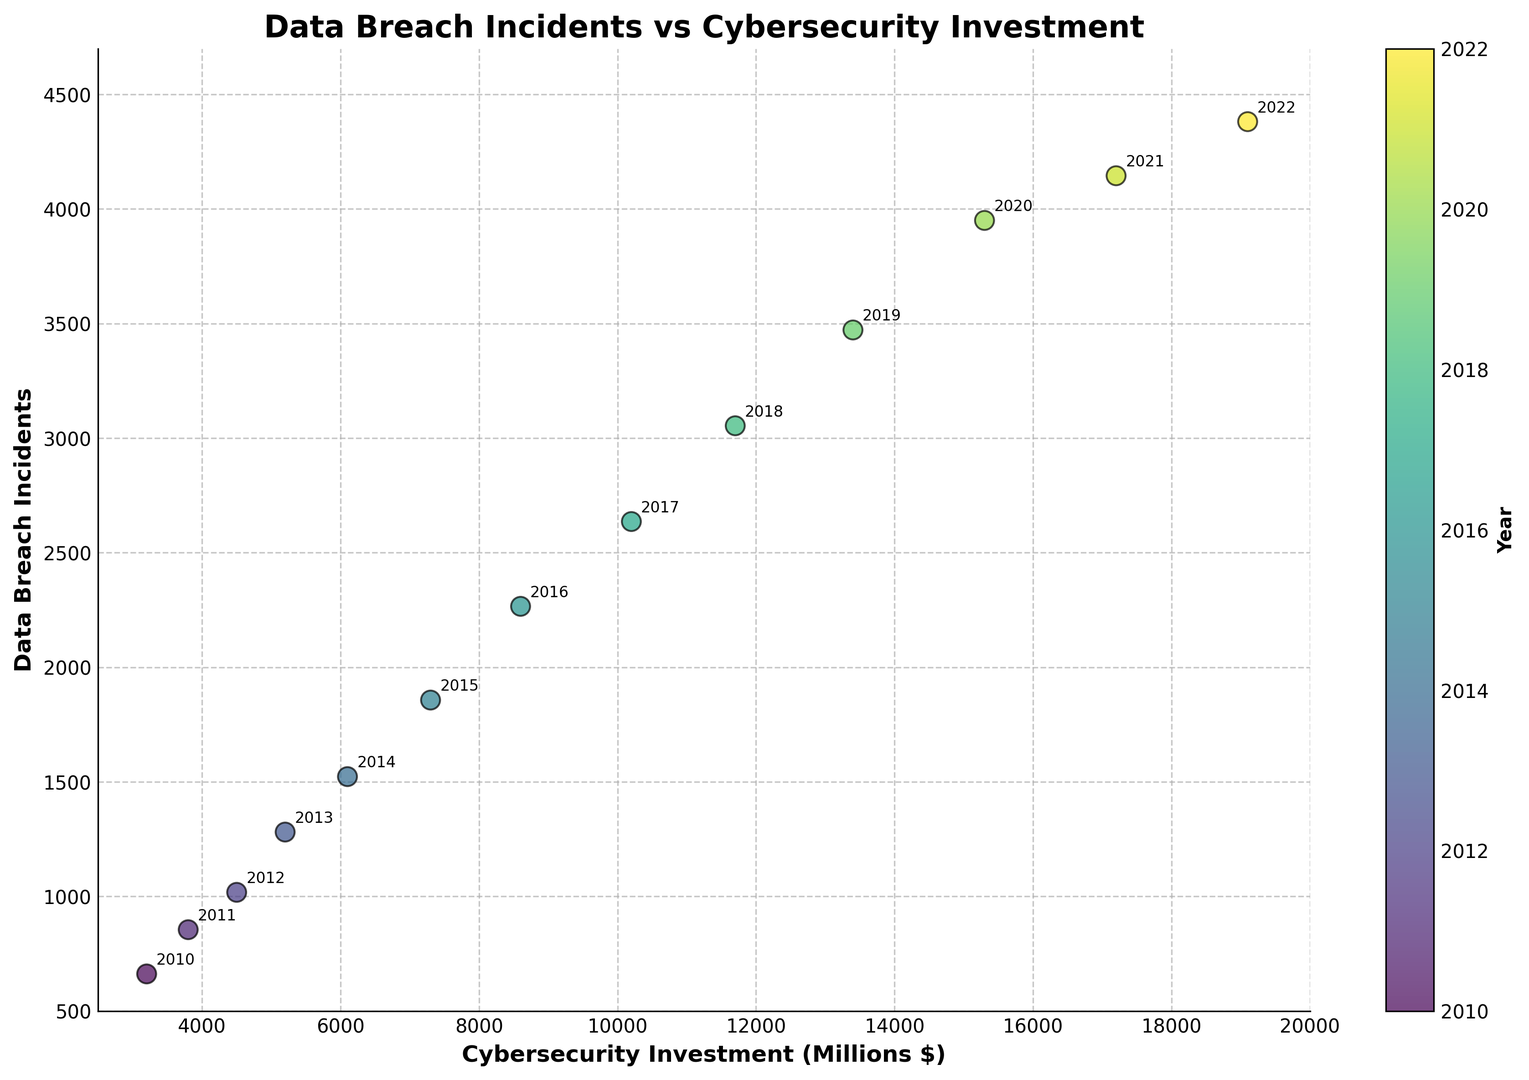Which year had the highest number of data breach incidents? The year corresponding to the highest point on the vertical axis indicates the maximum number of data breach incidents. From the plot, 2022 has the highest y-value.
Answer: 2022 Did the number of data breach incidents increase or decrease over the years despite increasing cybersecurity investment? Observing the trend as we move from left to right in the plot (which correlates to increasing investment), the number of data breach incidents also increases. This is evident as both x and y values increase over time.
Answer: Increase Between 2015 and 2020, by approximately how many millions did the cybersecurity investment increase? From the plot, locate the x-value for 2015 and 2020, which correspond to 7300 and 15300 respectively. The difference is 15300 - 7300 = 8000 million dollars.
Answer: 8000 What is the average number of data breach incidents for the years 2010, 2012, and 2014? Identifying points for 2010 (662), 2012 (1018), and 2014 (1523) from the plot. The average is computed as (662 + 1018 + 1523) / 3. \[sum: 662 + 1018 + 1523 = 3203\] \[avg: 3203 / 3 ≈ 1068\]
Answer: 1068 Compare the cybersecurity investment in 2016 with that in 2018. Which year had a higher investment and by how much? From the plot, 2016 corresponds to approximately 8600 and 2018 to 11700. The difference is calculated as 11700 - 8600 = 3100 million dollars. Thus, 2018 had a higher investment.
Answer: 2018, 3100 